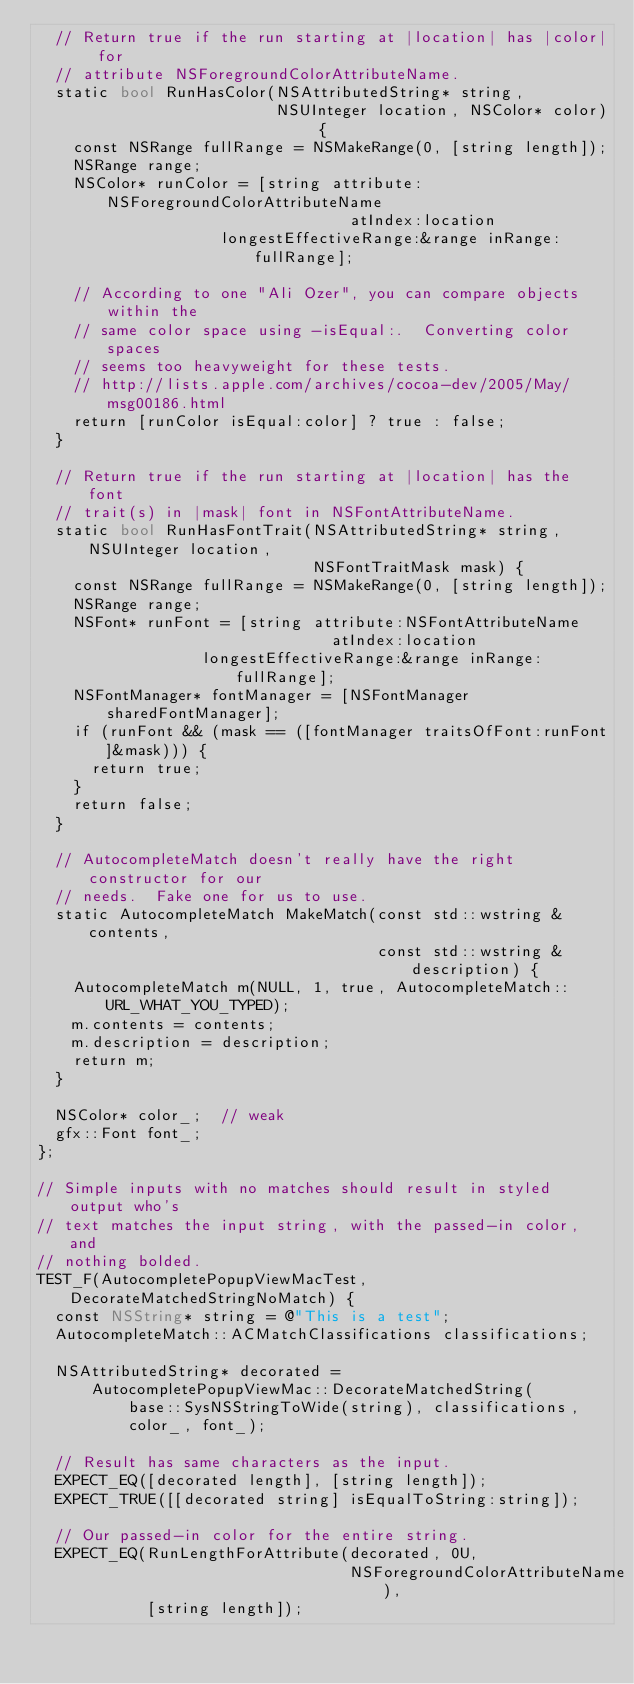Convert code to text. <code><loc_0><loc_0><loc_500><loc_500><_ObjectiveC_>  // Return true if the run starting at |location| has |color| for
  // attribute NSForegroundColorAttributeName.
  static bool RunHasColor(NSAttributedString* string,
                          NSUInteger location, NSColor* color) {
    const NSRange fullRange = NSMakeRange(0, [string length]);
    NSRange range;
    NSColor* runColor = [string attribute:NSForegroundColorAttributeName
                                  atIndex:location
                    longestEffectiveRange:&range inRange:fullRange];

    // According to one "Ali Ozer", you can compare objects within the
    // same color space using -isEqual:.  Converting color spaces
    // seems too heavyweight for these tests.
    // http://lists.apple.com/archives/cocoa-dev/2005/May/msg00186.html
    return [runColor isEqual:color] ? true : false;
  }

  // Return true if the run starting at |location| has the font
  // trait(s) in |mask| font in NSFontAttributeName.
  static bool RunHasFontTrait(NSAttributedString* string, NSUInteger location,
                              NSFontTraitMask mask) {
    const NSRange fullRange = NSMakeRange(0, [string length]);
    NSRange range;
    NSFont* runFont = [string attribute:NSFontAttributeName
                                atIndex:location
                  longestEffectiveRange:&range inRange:fullRange];
    NSFontManager* fontManager = [NSFontManager sharedFontManager];
    if (runFont && (mask == ([fontManager traitsOfFont:runFont]&mask))) {
      return true;
    }
    return false;
  }

  // AutocompleteMatch doesn't really have the right constructor for our
  // needs.  Fake one for us to use.
  static AutocompleteMatch MakeMatch(const std::wstring &contents,
                                     const std::wstring &description) {
    AutocompleteMatch m(NULL, 1, true, AutocompleteMatch::URL_WHAT_YOU_TYPED);
    m.contents = contents;
    m.description = description;
    return m;
  }

  NSColor* color_;  // weak
  gfx::Font font_;
};

// Simple inputs with no matches should result in styled output who's
// text matches the input string, with the passed-in color, and
// nothing bolded.
TEST_F(AutocompletePopupViewMacTest, DecorateMatchedStringNoMatch) {
  const NSString* string = @"This is a test";
  AutocompleteMatch::ACMatchClassifications classifications;

  NSAttributedString* decorated =
      AutocompletePopupViewMac::DecorateMatchedString(
          base::SysNSStringToWide(string), classifications,
          color_, font_);

  // Result has same characters as the input.
  EXPECT_EQ([decorated length], [string length]);
  EXPECT_TRUE([[decorated string] isEqualToString:string]);

  // Our passed-in color for the entire string.
  EXPECT_EQ(RunLengthForAttribute(decorated, 0U,
                                  NSForegroundColorAttributeName),
            [string length]);</code> 